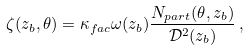Convert formula to latex. <formula><loc_0><loc_0><loc_500><loc_500>\zeta ( z _ { b } , \theta ) = \kappa _ { f a c } \omega ( z _ { b } ) \frac { N _ { p a r t } ( \theta , z _ { b } ) } { \mathcal { D } ^ { 2 } ( z _ { b } ) } \, ,</formula> 